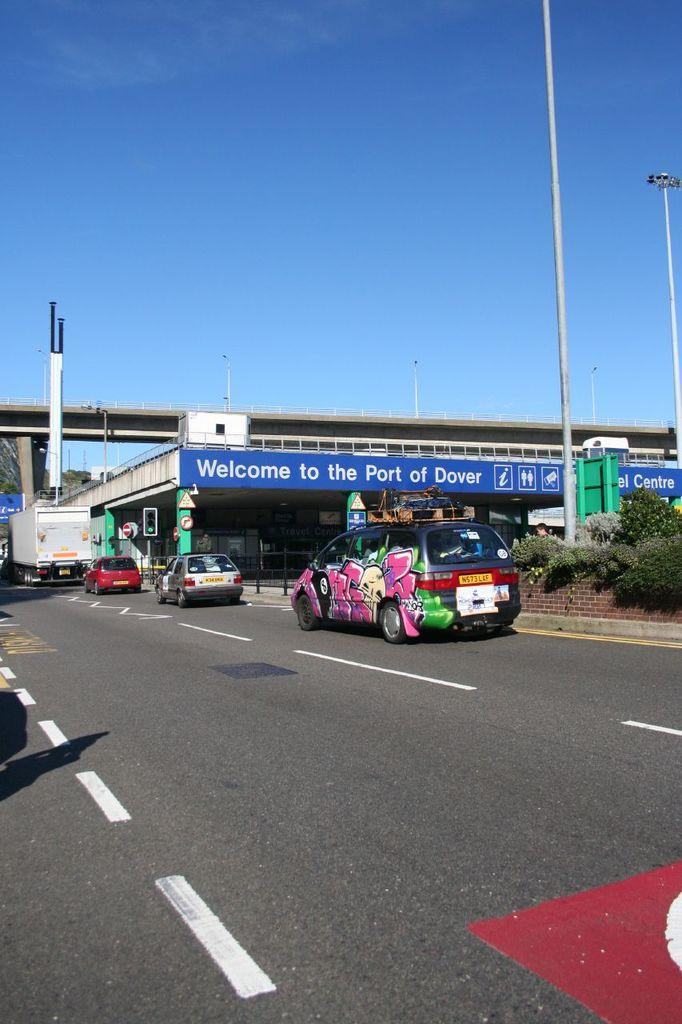What is the main feature of the image? There is a road in the image. What else can be seen on the road? There are vehicles in the image. Are there any structures along the road? Yes, there are poles and a board in the image. What type of vegetation is present in the image? There are plants in the image. Is there any infrastructure for traffic control? Yes, there is a bridge, a traffic signal, and a wall in the image. What else can be found in the image? There are other objects in the image. What can be seen in the background of the image? The sky is visible in the background of the image. What type of locket is hanging from the traffic signal in the image? There is no locket present in the image, as it is a traffic signal on a pole. Can you see the mind of the person driving the vehicle in the image? The image does not show the mind of the person driving the vehicle, as it is not possible to see someone's mind. 